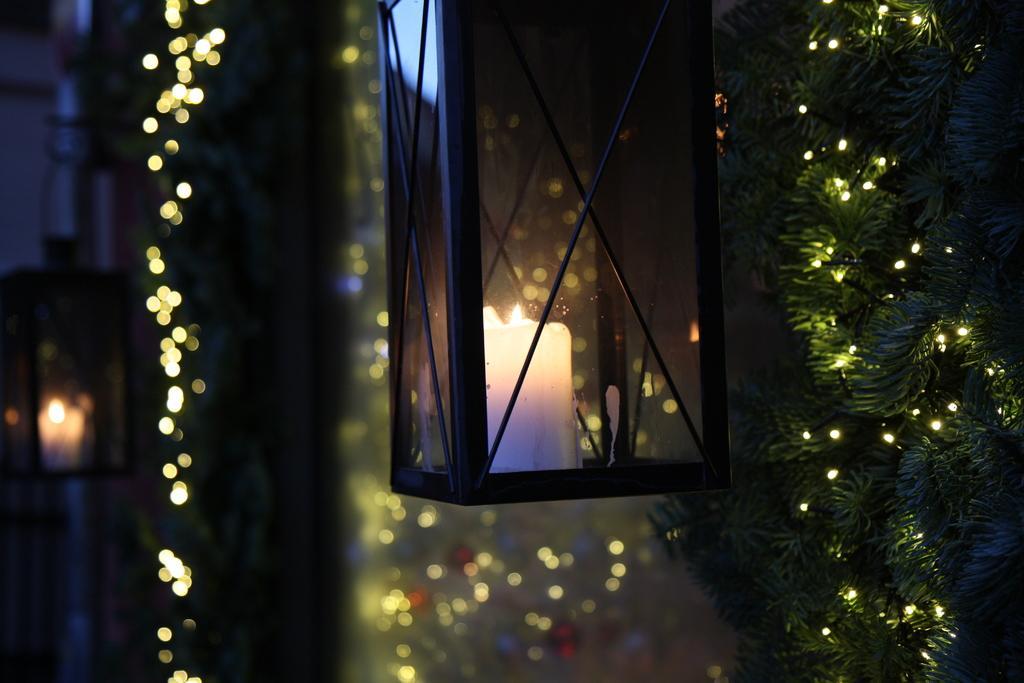Can you describe this image briefly? In this image we can see a candle is kept in the glass box. Here we can see the decorative items. The background of the image is slightly blurred, where we can see lights and another candle kept in the glass box. 